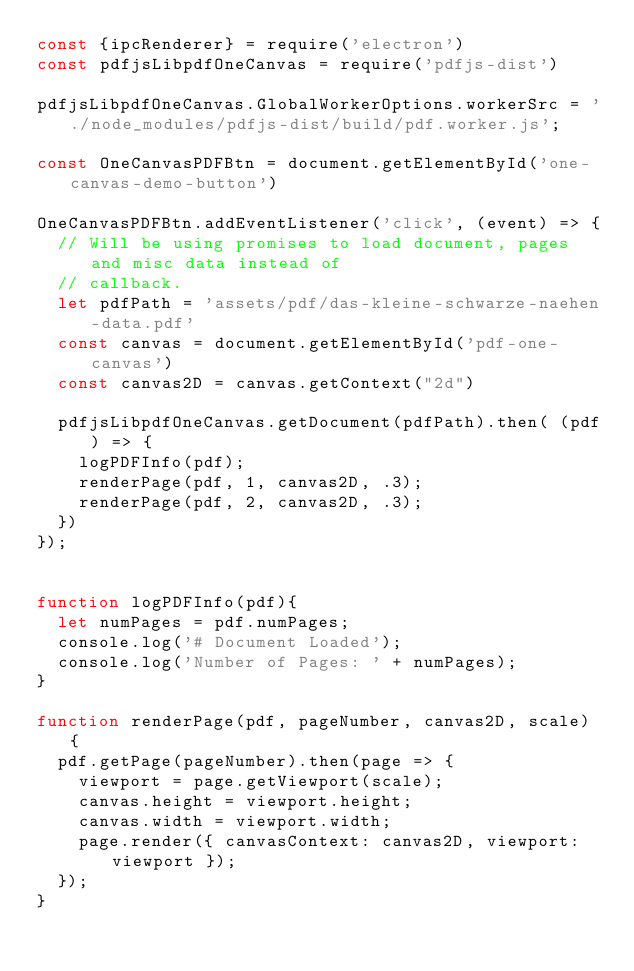Convert code to text. <code><loc_0><loc_0><loc_500><loc_500><_JavaScript_>const {ipcRenderer} = require('electron')
const pdfjsLibpdfOneCanvas = require('pdfjs-dist')

pdfjsLibpdfOneCanvas.GlobalWorkerOptions.workerSrc = './node_modules/pdfjs-dist/build/pdf.worker.js';

const OneCanvasPDFBtn = document.getElementById('one-canvas-demo-button')

OneCanvasPDFBtn.addEventListener('click', (event) => {
  // Will be using promises to load document, pages and misc data instead of
  // callback.
  let pdfPath = 'assets/pdf/das-kleine-schwarze-naehen-data.pdf'
  const canvas = document.getElementById('pdf-one-canvas')
  const canvas2D = canvas.getContext("2d")

  pdfjsLibpdfOneCanvas.getDocument(pdfPath).then( (pdf) => {
    logPDFInfo(pdf);
    renderPage(pdf, 1, canvas2D, .3);
    renderPage(pdf, 2, canvas2D, .3);
  })
});


function logPDFInfo(pdf){
  let numPages = pdf.numPages;
  console.log('# Document Loaded');
  console.log('Number of Pages: ' + numPages);
}

function renderPage(pdf, pageNumber, canvas2D, scale) {
  pdf.getPage(pageNumber).then(page => {
    viewport = page.getViewport(scale);
    canvas.height = viewport.height;
    canvas.width = viewport.width;
    page.render({ canvasContext: canvas2D, viewport: viewport });
  });
}</code> 